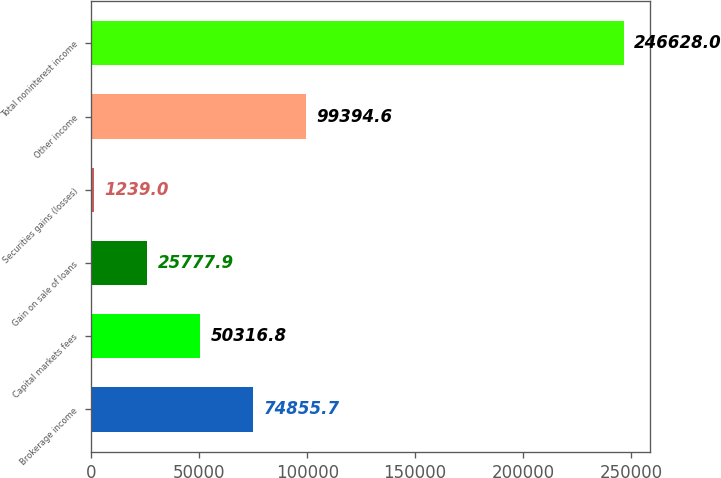Convert chart to OTSL. <chart><loc_0><loc_0><loc_500><loc_500><bar_chart><fcel>Brokerage income<fcel>Capital markets fees<fcel>Gain on sale of loans<fcel>Securities gains (losses)<fcel>Other income<fcel>Total noninterest income<nl><fcel>74855.7<fcel>50316.8<fcel>25777.9<fcel>1239<fcel>99394.6<fcel>246628<nl></chart> 